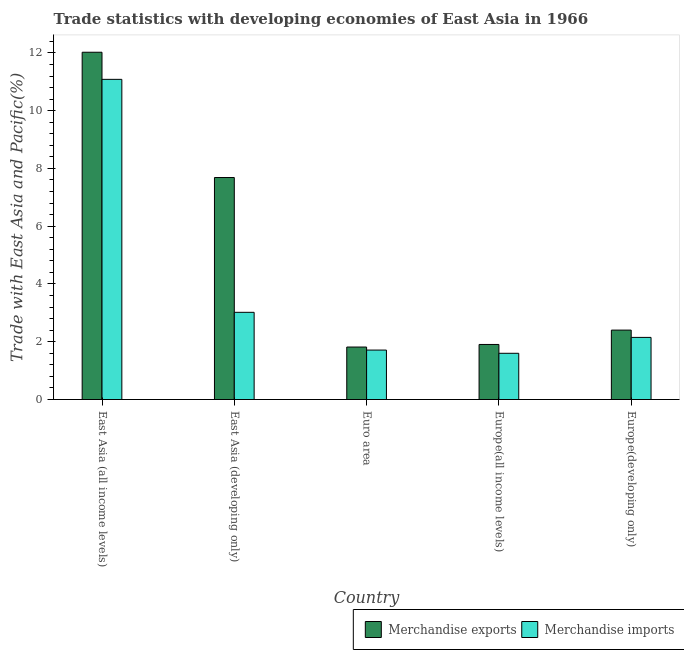How many different coloured bars are there?
Give a very brief answer. 2. How many groups of bars are there?
Your response must be concise. 5. Are the number of bars per tick equal to the number of legend labels?
Provide a short and direct response. Yes. How many bars are there on the 2nd tick from the left?
Your answer should be very brief. 2. How many bars are there on the 4th tick from the right?
Provide a short and direct response. 2. What is the label of the 5th group of bars from the left?
Your answer should be very brief. Europe(developing only). In how many cases, is the number of bars for a given country not equal to the number of legend labels?
Offer a terse response. 0. What is the merchandise exports in East Asia (all income levels)?
Provide a succinct answer. 12.02. Across all countries, what is the maximum merchandise imports?
Offer a terse response. 11.08. Across all countries, what is the minimum merchandise imports?
Offer a very short reply. 1.6. In which country was the merchandise exports maximum?
Provide a succinct answer. East Asia (all income levels). In which country was the merchandise imports minimum?
Give a very brief answer. Europe(all income levels). What is the total merchandise exports in the graph?
Provide a short and direct response. 25.83. What is the difference between the merchandise exports in East Asia (all income levels) and that in East Asia (developing only)?
Offer a very short reply. 4.34. What is the difference between the merchandise exports in East Asia (developing only) and the merchandise imports in Europe(developing only)?
Offer a very short reply. 5.53. What is the average merchandise imports per country?
Offer a terse response. 3.91. What is the difference between the merchandise exports and merchandise imports in Europe(developing only)?
Offer a terse response. 0.25. What is the ratio of the merchandise exports in East Asia (all income levels) to that in East Asia (developing only)?
Ensure brevity in your answer.  1.56. Is the merchandise exports in East Asia (developing only) less than that in Euro area?
Make the answer very short. No. Is the difference between the merchandise exports in Euro area and Europe(developing only) greater than the difference between the merchandise imports in Euro area and Europe(developing only)?
Ensure brevity in your answer.  No. What is the difference between the highest and the second highest merchandise imports?
Offer a terse response. 8.07. What is the difference between the highest and the lowest merchandise imports?
Provide a short and direct response. 9.48. In how many countries, is the merchandise imports greater than the average merchandise imports taken over all countries?
Ensure brevity in your answer.  1. Is the sum of the merchandise exports in East Asia (all income levels) and East Asia (developing only) greater than the maximum merchandise imports across all countries?
Provide a succinct answer. Yes. What does the 2nd bar from the right in Europe(developing only) represents?
Provide a short and direct response. Merchandise exports. Are all the bars in the graph horizontal?
Offer a very short reply. No. How many countries are there in the graph?
Your response must be concise. 5. What is the difference between two consecutive major ticks on the Y-axis?
Your answer should be compact. 2. Does the graph contain any zero values?
Give a very brief answer. No. How many legend labels are there?
Ensure brevity in your answer.  2. How are the legend labels stacked?
Your response must be concise. Horizontal. What is the title of the graph?
Make the answer very short. Trade statistics with developing economies of East Asia in 1966. Does "Highest 10% of population" appear as one of the legend labels in the graph?
Provide a short and direct response. No. What is the label or title of the X-axis?
Give a very brief answer. Country. What is the label or title of the Y-axis?
Make the answer very short. Trade with East Asia and Pacific(%). What is the Trade with East Asia and Pacific(%) in Merchandise exports in East Asia (all income levels)?
Keep it short and to the point. 12.02. What is the Trade with East Asia and Pacific(%) in Merchandise imports in East Asia (all income levels)?
Provide a succinct answer. 11.08. What is the Trade with East Asia and Pacific(%) in Merchandise exports in East Asia (developing only)?
Keep it short and to the point. 7.69. What is the Trade with East Asia and Pacific(%) of Merchandise imports in East Asia (developing only)?
Provide a short and direct response. 3.02. What is the Trade with East Asia and Pacific(%) in Merchandise exports in Euro area?
Give a very brief answer. 1.82. What is the Trade with East Asia and Pacific(%) of Merchandise imports in Euro area?
Your answer should be compact. 1.71. What is the Trade with East Asia and Pacific(%) in Merchandise exports in Europe(all income levels)?
Your answer should be very brief. 1.91. What is the Trade with East Asia and Pacific(%) of Merchandise imports in Europe(all income levels)?
Provide a succinct answer. 1.6. What is the Trade with East Asia and Pacific(%) in Merchandise exports in Europe(developing only)?
Make the answer very short. 2.4. What is the Trade with East Asia and Pacific(%) of Merchandise imports in Europe(developing only)?
Your answer should be very brief. 2.15. Across all countries, what is the maximum Trade with East Asia and Pacific(%) of Merchandise exports?
Offer a very short reply. 12.02. Across all countries, what is the maximum Trade with East Asia and Pacific(%) in Merchandise imports?
Provide a succinct answer. 11.08. Across all countries, what is the minimum Trade with East Asia and Pacific(%) of Merchandise exports?
Give a very brief answer. 1.82. Across all countries, what is the minimum Trade with East Asia and Pacific(%) of Merchandise imports?
Your answer should be very brief. 1.6. What is the total Trade with East Asia and Pacific(%) in Merchandise exports in the graph?
Make the answer very short. 25.83. What is the total Trade with East Asia and Pacific(%) of Merchandise imports in the graph?
Give a very brief answer. 19.57. What is the difference between the Trade with East Asia and Pacific(%) in Merchandise exports in East Asia (all income levels) and that in East Asia (developing only)?
Your response must be concise. 4.34. What is the difference between the Trade with East Asia and Pacific(%) in Merchandise imports in East Asia (all income levels) and that in East Asia (developing only)?
Your response must be concise. 8.07. What is the difference between the Trade with East Asia and Pacific(%) of Merchandise exports in East Asia (all income levels) and that in Euro area?
Your answer should be compact. 10.21. What is the difference between the Trade with East Asia and Pacific(%) of Merchandise imports in East Asia (all income levels) and that in Euro area?
Your response must be concise. 9.37. What is the difference between the Trade with East Asia and Pacific(%) of Merchandise exports in East Asia (all income levels) and that in Europe(all income levels)?
Make the answer very short. 10.12. What is the difference between the Trade with East Asia and Pacific(%) in Merchandise imports in East Asia (all income levels) and that in Europe(all income levels)?
Your answer should be compact. 9.48. What is the difference between the Trade with East Asia and Pacific(%) of Merchandise exports in East Asia (all income levels) and that in Europe(developing only)?
Offer a terse response. 9.62. What is the difference between the Trade with East Asia and Pacific(%) of Merchandise imports in East Asia (all income levels) and that in Europe(developing only)?
Keep it short and to the point. 8.93. What is the difference between the Trade with East Asia and Pacific(%) in Merchandise exports in East Asia (developing only) and that in Euro area?
Make the answer very short. 5.87. What is the difference between the Trade with East Asia and Pacific(%) of Merchandise imports in East Asia (developing only) and that in Euro area?
Your answer should be very brief. 1.31. What is the difference between the Trade with East Asia and Pacific(%) in Merchandise exports in East Asia (developing only) and that in Europe(all income levels)?
Ensure brevity in your answer.  5.78. What is the difference between the Trade with East Asia and Pacific(%) of Merchandise imports in East Asia (developing only) and that in Europe(all income levels)?
Your answer should be very brief. 1.42. What is the difference between the Trade with East Asia and Pacific(%) in Merchandise exports in East Asia (developing only) and that in Europe(developing only)?
Keep it short and to the point. 5.28. What is the difference between the Trade with East Asia and Pacific(%) of Merchandise imports in East Asia (developing only) and that in Europe(developing only)?
Provide a short and direct response. 0.87. What is the difference between the Trade with East Asia and Pacific(%) of Merchandise exports in Euro area and that in Europe(all income levels)?
Your response must be concise. -0.09. What is the difference between the Trade with East Asia and Pacific(%) in Merchandise imports in Euro area and that in Europe(all income levels)?
Your answer should be very brief. 0.11. What is the difference between the Trade with East Asia and Pacific(%) in Merchandise exports in Euro area and that in Europe(developing only)?
Keep it short and to the point. -0.59. What is the difference between the Trade with East Asia and Pacific(%) of Merchandise imports in Euro area and that in Europe(developing only)?
Your answer should be very brief. -0.44. What is the difference between the Trade with East Asia and Pacific(%) of Merchandise exports in Europe(all income levels) and that in Europe(developing only)?
Provide a succinct answer. -0.5. What is the difference between the Trade with East Asia and Pacific(%) in Merchandise imports in Europe(all income levels) and that in Europe(developing only)?
Your answer should be compact. -0.55. What is the difference between the Trade with East Asia and Pacific(%) in Merchandise exports in East Asia (all income levels) and the Trade with East Asia and Pacific(%) in Merchandise imports in East Asia (developing only)?
Your answer should be compact. 9. What is the difference between the Trade with East Asia and Pacific(%) in Merchandise exports in East Asia (all income levels) and the Trade with East Asia and Pacific(%) in Merchandise imports in Euro area?
Offer a very short reply. 10.31. What is the difference between the Trade with East Asia and Pacific(%) in Merchandise exports in East Asia (all income levels) and the Trade with East Asia and Pacific(%) in Merchandise imports in Europe(all income levels)?
Provide a succinct answer. 10.42. What is the difference between the Trade with East Asia and Pacific(%) of Merchandise exports in East Asia (all income levels) and the Trade with East Asia and Pacific(%) of Merchandise imports in Europe(developing only)?
Your response must be concise. 9.87. What is the difference between the Trade with East Asia and Pacific(%) of Merchandise exports in East Asia (developing only) and the Trade with East Asia and Pacific(%) of Merchandise imports in Euro area?
Your response must be concise. 5.97. What is the difference between the Trade with East Asia and Pacific(%) of Merchandise exports in East Asia (developing only) and the Trade with East Asia and Pacific(%) of Merchandise imports in Europe(all income levels)?
Your answer should be very brief. 6.08. What is the difference between the Trade with East Asia and Pacific(%) of Merchandise exports in East Asia (developing only) and the Trade with East Asia and Pacific(%) of Merchandise imports in Europe(developing only)?
Give a very brief answer. 5.53. What is the difference between the Trade with East Asia and Pacific(%) of Merchandise exports in Euro area and the Trade with East Asia and Pacific(%) of Merchandise imports in Europe(all income levels)?
Your answer should be very brief. 0.22. What is the difference between the Trade with East Asia and Pacific(%) of Merchandise exports in Euro area and the Trade with East Asia and Pacific(%) of Merchandise imports in Europe(developing only)?
Give a very brief answer. -0.33. What is the difference between the Trade with East Asia and Pacific(%) in Merchandise exports in Europe(all income levels) and the Trade with East Asia and Pacific(%) in Merchandise imports in Europe(developing only)?
Your answer should be very brief. -0.24. What is the average Trade with East Asia and Pacific(%) of Merchandise exports per country?
Offer a terse response. 5.17. What is the average Trade with East Asia and Pacific(%) of Merchandise imports per country?
Your answer should be compact. 3.91. What is the difference between the Trade with East Asia and Pacific(%) in Merchandise exports and Trade with East Asia and Pacific(%) in Merchandise imports in East Asia (all income levels)?
Make the answer very short. 0.94. What is the difference between the Trade with East Asia and Pacific(%) in Merchandise exports and Trade with East Asia and Pacific(%) in Merchandise imports in East Asia (developing only)?
Offer a very short reply. 4.67. What is the difference between the Trade with East Asia and Pacific(%) in Merchandise exports and Trade with East Asia and Pacific(%) in Merchandise imports in Euro area?
Ensure brevity in your answer.  0.1. What is the difference between the Trade with East Asia and Pacific(%) of Merchandise exports and Trade with East Asia and Pacific(%) of Merchandise imports in Europe(all income levels)?
Provide a short and direct response. 0.31. What is the difference between the Trade with East Asia and Pacific(%) in Merchandise exports and Trade with East Asia and Pacific(%) in Merchandise imports in Europe(developing only)?
Your answer should be very brief. 0.25. What is the ratio of the Trade with East Asia and Pacific(%) in Merchandise exports in East Asia (all income levels) to that in East Asia (developing only)?
Provide a short and direct response. 1.56. What is the ratio of the Trade with East Asia and Pacific(%) in Merchandise imports in East Asia (all income levels) to that in East Asia (developing only)?
Provide a short and direct response. 3.67. What is the ratio of the Trade with East Asia and Pacific(%) of Merchandise exports in East Asia (all income levels) to that in Euro area?
Your response must be concise. 6.62. What is the ratio of the Trade with East Asia and Pacific(%) in Merchandise imports in East Asia (all income levels) to that in Euro area?
Give a very brief answer. 6.47. What is the ratio of the Trade with East Asia and Pacific(%) in Merchandise exports in East Asia (all income levels) to that in Europe(all income levels)?
Provide a succinct answer. 6.31. What is the ratio of the Trade with East Asia and Pacific(%) in Merchandise imports in East Asia (all income levels) to that in Europe(all income levels)?
Keep it short and to the point. 6.92. What is the ratio of the Trade with East Asia and Pacific(%) of Merchandise exports in East Asia (all income levels) to that in Europe(developing only)?
Your response must be concise. 5. What is the ratio of the Trade with East Asia and Pacific(%) in Merchandise imports in East Asia (all income levels) to that in Europe(developing only)?
Your response must be concise. 5.15. What is the ratio of the Trade with East Asia and Pacific(%) of Merchandise exports in East Asia (developing only) to that in Euro area?
Give a very brief answer. 4.23. What is the ratio of the Trade with East Asia and Pacific(%) in Merchandise imports in East Asia (developing only) to that in Euro area?
Keep it short and to the point. 1.76. What is the ratio of the Trade with East Asia and Pacific(%) of Merchandise exports in East Asia (developing only) to that in Europe(all income levels)?
Give a very brief answer. 4.03. What is the ratio of the Trade with East Asia and Pacific(%) of Merchandise imports in East Asia (developing only) to that in Europe(all income levels)?
Offer a terse response. 1.89. What is the ratio of the Trade with East Asia and Pacific(%) in Merchandise exports in East Asia (developing only) to that in Europe(developing only)?
Your answer should be very brief. 3.2. What is the ratio of the Trade with East Asia and Pacific(%) of Merchandise imports in East Asia (developing only) to that in Europe(developing only)?
Ensure brevity in your answer.  1.4. What is the ratio of the Trade with East Asia and Pacific(%) in Merchandise exports in Euro area to that in Europe(all income levels)?
Offer a very short reply. 0.95. What is the ratio of the Trade with East Asia and Pacific(%) in Merchandise imports in Euro area to that in Europe(all income levels)?
Make the answer very short. 1.07. What is the ratio of the Trade with East Asia and Pacific(%) of Merchandise exports in Euro area to that in Europe(developing only)?
Keep it short and to the point. 0.76. What is the ratio of the Trade with East Asia and Pacific(%) of Merchandise imports in Euro area to that in Europe(developing only)?
Your response must be concise. 0.8. What is the ratio of the Trade with East Asia and Pacific(%) in Merchandise exports in Europe(all income levels) to that in Europe(developing only)?
Provide a succinct answer. 0.79. What is the ratio of the Trade with East Asia and Pacific(%) of Merchandise imports in Europe(all income levels) to that in Europe(developing only)?
Your answer should be very brief. 0.74. What is the difference between the highest and the second highest Trade with East Asia and Pacific(%) in Merchandise exports?
Your response must be concise. 4.34. What is the difference between the highest and the second highest Trade with East Asia and Pacific(%) in Merchandise imports?
Ensure brevity in your answer.  8.07. What is the difference between the highest and the lowest Trade with East Asia and Pacific(%) of Merchandise exports?
Keep it short and to the point. 10.21. What is the difference between the highest and the lowest Trade with East Asia and Pacific(%) of Merchandise imports?
Offer a very short reply. 9.48. 